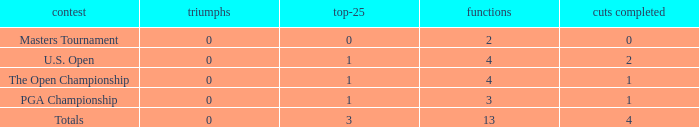How many cuts made in the tournament he played 13 times? None. 